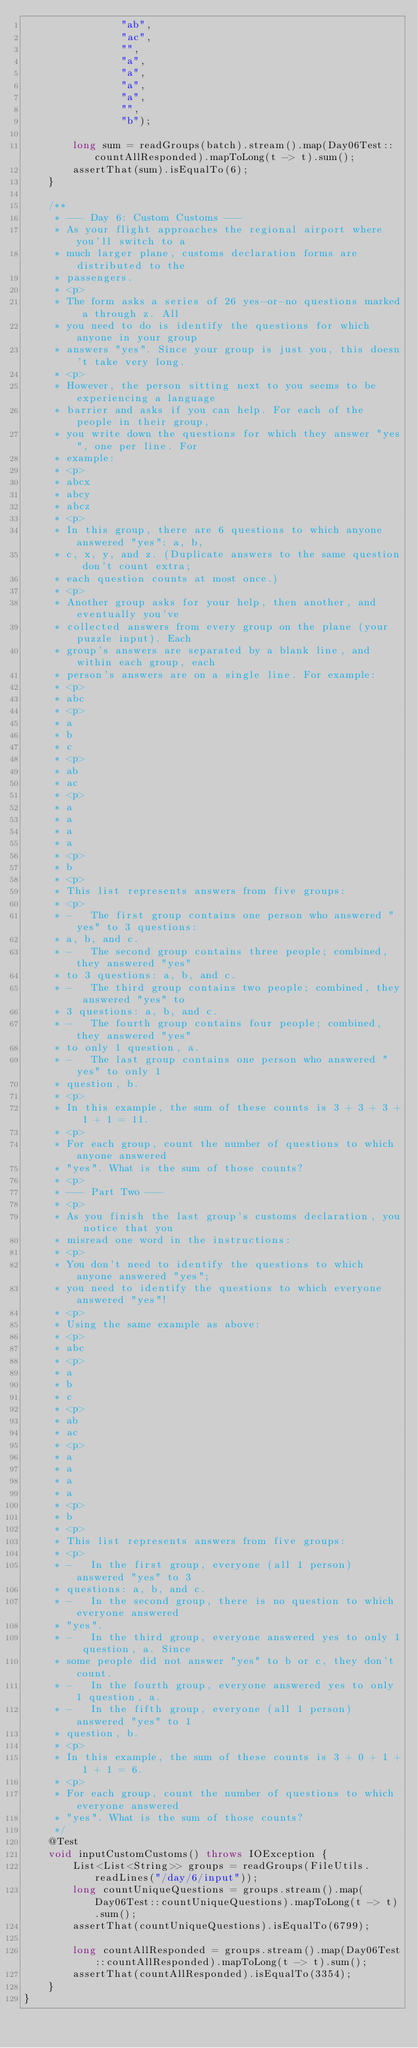Convert code to text. <code><loc_0><loc_0><loc_500><loc_500><_Java_>                "ab",
                "ac",
                "",
                "a",
                "a",
                "a",
                "a",
                "",
                "b");

        long sum = readGroups(batch).stream().map(Day06Test::countAllResponded).mapToLong(t -> t).sum();
        assertThat(sum).isEqualTo(6);
    }

    /**
     * --- Day 6: Custom Customs ---
     * As your flight approaches the regional airport where you'll switch to a
     * much larger plane, customs declaration forms are distributed to the
     * passengers.
     * <p>
     * The form asks a series of 26 yes-or-no questions marked a through z. All
     * you need to do is identify the questions for which anyone in your group
     * answers "yes". Since your group is just you, this doesn't take very long.
     * <p>
     * However, the person sitting next to you seems to be experiencing a language
     * barrier and asks if you can help. For each of the people in their group,
     * you write down the questions for which they answer "yes", one per line. For
     * example:
     * <p>
     * abcx
     * abcy
     * abcz
     * <p>
     * In this group, there are 6 questions to which anyone answered "yes": a, b,
     * c, x, y, and z. (Duplicate answers to the same question don't count extra;
     * each question counts at most once.)
     * <p>
     * Another group asks for your help, then another, and eventually you've
     * collected answers from every group on the plane (your puzzle input). Each
     * group's answers are separated by a blank line, and within each group, each
     * person's answers are on a single line. For example:
     * <p>
     * abc
     * <p>
     * a
     * b
     * c
     * <p>
     * ab
     * ac
     * <p>
     * a
     * a
     * a
     * a
     * <p>
     * b
     * <p>
     * This list represents answers from five groups:
     * <p>
     * -   The first group contains one person who answered "yes" to 3 questions:
     * a, b, and c.
     * -   The second group contains three people; combined, they answered "yes"
     * to 3 questions: a, b, and c.
     * -   The third group contains two people; combined, they answered "yes" to
     * 3 questions: a, b, and c.
     * -   The fourth group contains four people; combined, they answered "yes"
     * to only 1 question, a.
     * -   The last group contains one person who answered "yes" to only 1
     * question, b.
     * <p>
     * In this example, the sum of these counts is 3 + 3 + 3 + 1 + 1 = 11.
     * <p>
     * For each group, count the number of questions to which anyone answered
     * "yes". What is the sum of those counts?
     * <p>
     * --- Part Two ---
     * <p>
     * As you finish the last group's customs declaration, you notice that you
     * misread one word in the instructions:
     * <p>
     * You don't need to identify the questions to which anyone answered "yes";
     * you need to identify the questions to which everyone answered "yes"!
     * <p>
     * Using the same example as above:
     * <p>
     * abc
     * <p>
     * a
     * b
     * c
     * <p>
     * ab
     * ac
     * <p>
     * a
     * a
     * a
     * a
     * <p>
     * b
     * <p>
     * This list represents answers from five groups:
     * <p>
     * -   In the first group, everyone (all 1 person) answered "yes" to 3
     * questions: a, b, and c.
     * -   In the second group, there is no question to which everyone answered
     * "yes".
     * -   In the third group, everyone answered yes to only 1 question, a. Since
     * some people did not answer "yes" to b or c, they don't count.
     * -   In the fourth group, everyone answered yes to only 1 question, a.
     * -   In the fifth group, everyone (all 1 person) answered "yes" to 1
     * question, b.
     * <p>
     * In this example, the sum of these counts is 3 + 0 + 1 + 1 + 1 = 6.
     * <p>
     * For each group, count the number of questions to which everyone answered
     * "yes". What is the sum of those counts?
     */
    @Test
    void inputCustomCustoms() throws IOException {
        List<List<String>> groups = readGroups(FileUtils.readLines("/day/6/input"));
        long countUniqueQuestions = groups.stream().map(Day06Test::countUniqueQuestions).mapToLong(t -> t).sum();
        assertThat(countUniqueQuestions).isEqualTo(6799);

        long countAllResponded = groups.stream().map(Day06Test::countAllResponded).mapToLong(t -> t).sum();
        assertThat(countAllResponded).isEqualTo(3354);
    }
}
</code> 